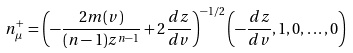<formula> <loc_0><loc_0><loc_500><loc_500>n _ { \mu } ^ { + } = \left ( - \frac { 2 m ( v ) } { ( n - 1 ) z ^ { n - 1 } } + 2 \frac { d z } { d v } \right ) ^ { - 1 / 2 } \left ( - \frac { d z } { d v } , 1 , 0 , \dots , 0 \right )</formula> 